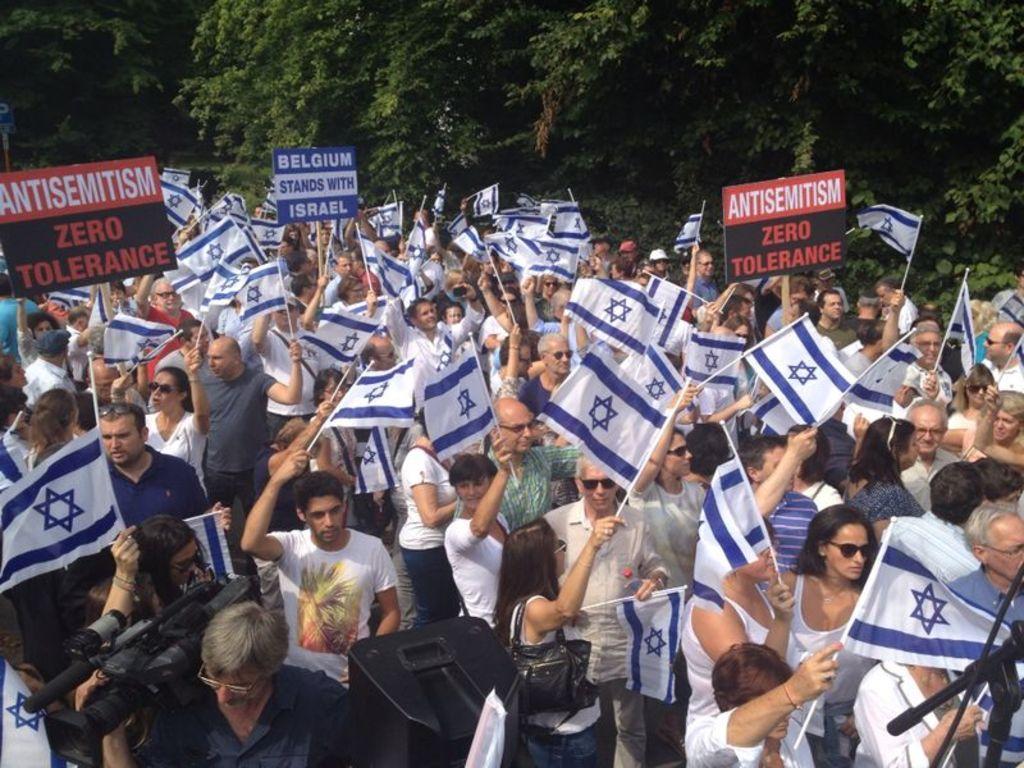In one or two sentences, can you explain what this image depicts? In this image, we can see people holding flags and boards. In the background, there are trees. 